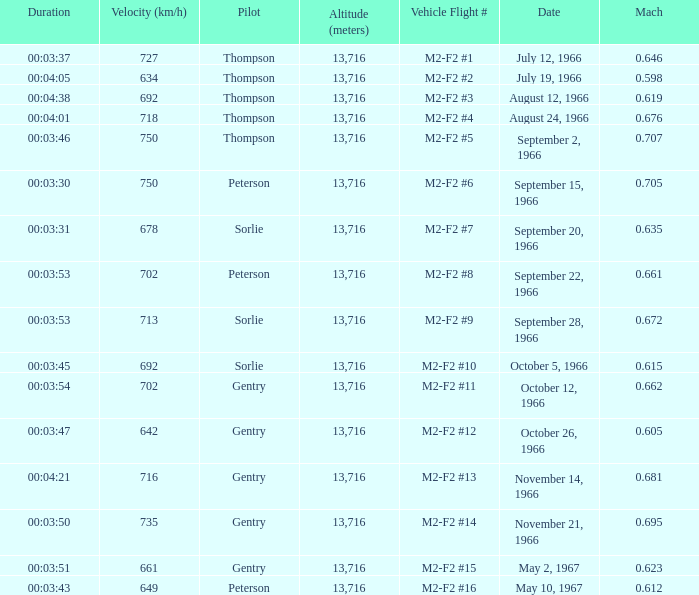What is the Mach with Vehicle Flight # m2-f2 #8 and an Altitude (meters) greater than 13,716? None. 